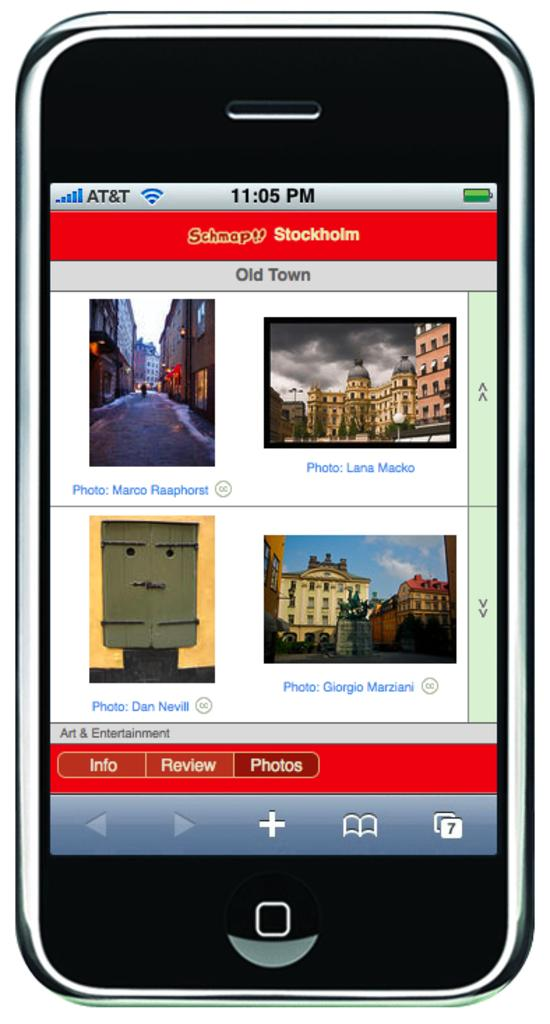<image>
Render a clear and concise summary of the photo. the word photos is on the area under the pictures 